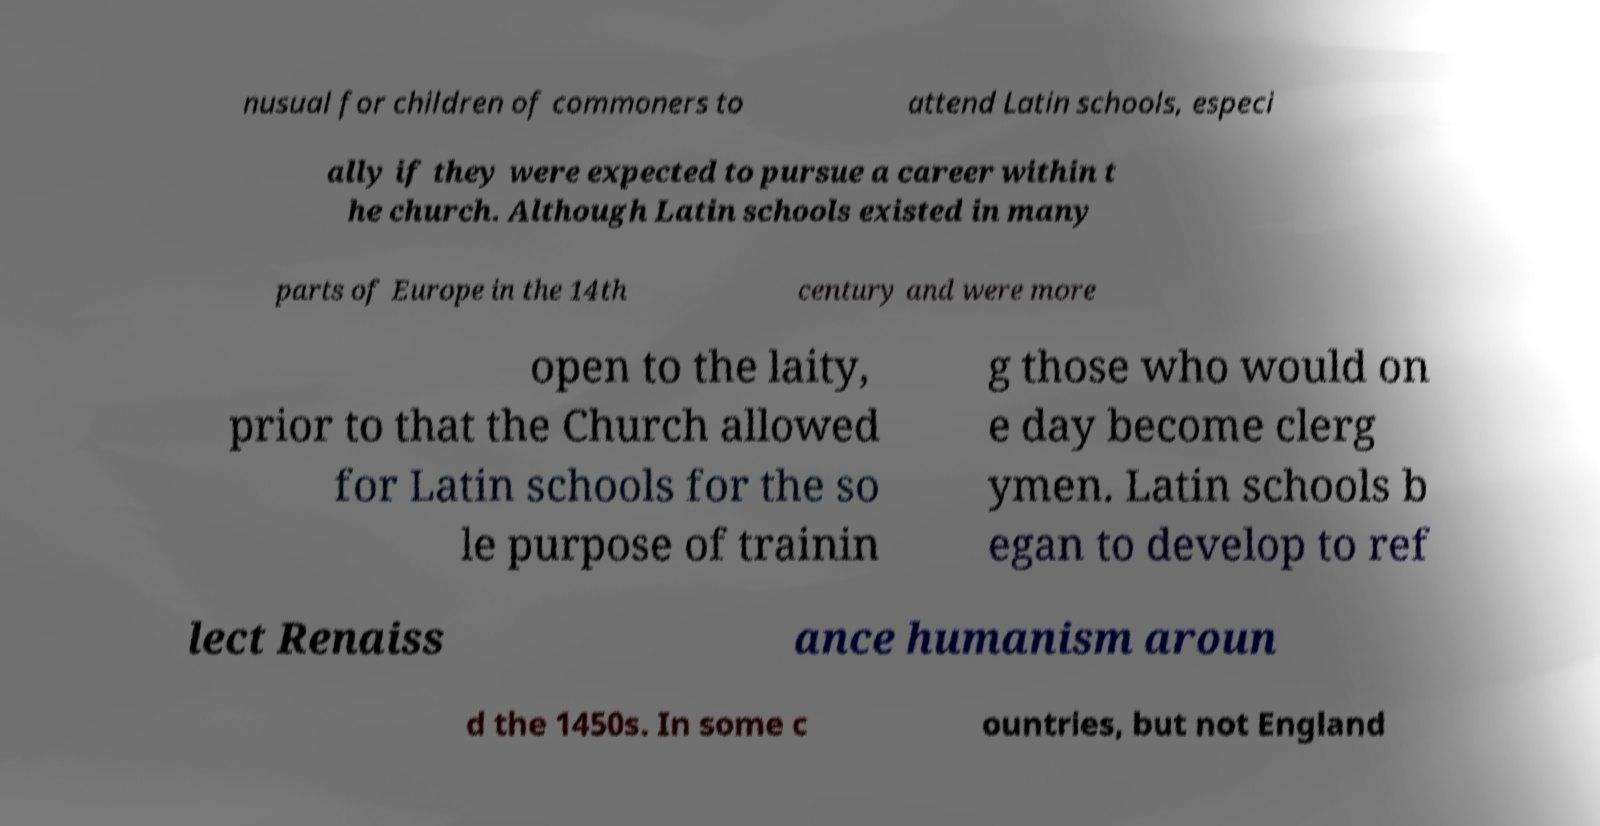What messages or text are displayed in this image? I need them in a readable, typed format. nusual for children of commoners to attend Latin schools, especi ally if they were expected to pursue a career within t he church. Although Latin schools existed in many parts of Europe in the 14th century and were more open to the laity, prior to that the Church allowed for Latin schools for the so le purpose of trainin g those who would on e day become clerg ymen. Latin schools b egan to develop to ref lect Renaiss ance humanism aroun d the 1450s. In some c ountries, but not England 